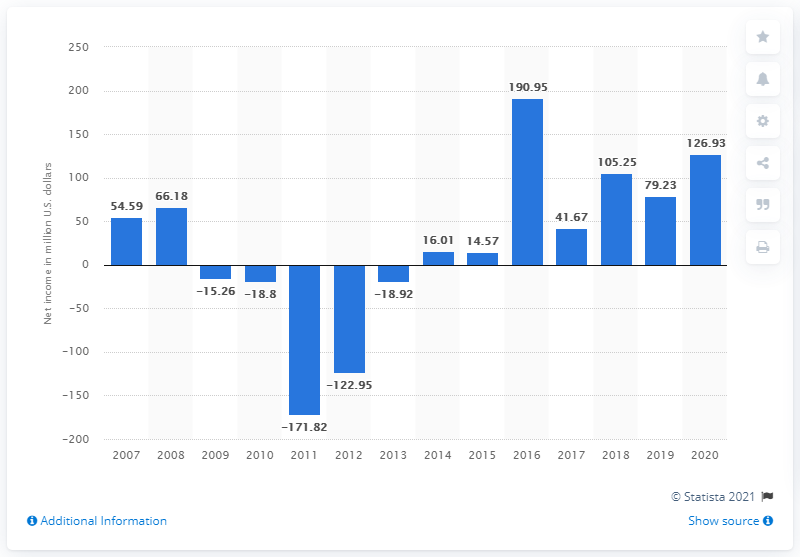Identify some key points in this picture. In 2020, Callaway Golf's net income was $126.93 million. 